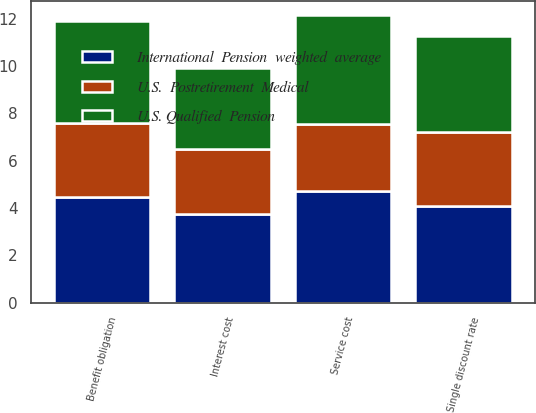Convert chart to OTSL. <chart><loc_0><loc_0><loc_500><loc_500><stacked_bar_chart><ecel><fcel>Single discount rate<fcel>Benefit obligation<fcel>Service cost<fcel>Interest cost<nl><fcel>International  Pension  weighted  average<fcel>4.1<fcel>4.47<fcel>4.72<fcel>3.77<nl><fcel>U.S.  Postretirement  Medical<fcel>3.11<fcel>3.12<fcel>2.84<fcel>2.72<nl><fcel>U.S. Qualified  Pension<fcel>4.07<fcel>4.32<fcel>4.6<fcel>3.44<nl></chart> 